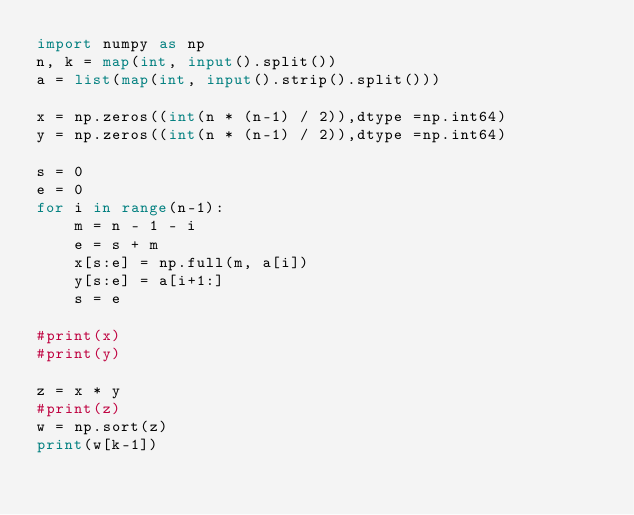Convert code to text. <code><loc_0><loc_0><loc_500><loc_500><_Python_>import numpy as np
n, k = map(int, input().split())
a = list(map(int, input().strip().split()))

x = np.zeros((int(n * (n-1) / 2)),dtype =np.int64)
y = np.zeros((int(n * (n-1) / 2)),dtype =np.int64)

s = 0
e = 0
for i in range(n-1):
    m = n - 1 - i
    e = s + m
    x[s:e] = np.full(m, a[i])
    y[s:e] = a[i+1:]
    s = e

#print(x)
#print(y)

z = x * y
#print(z)
w = np.sort(z)
print(w[k-1])
</code> 